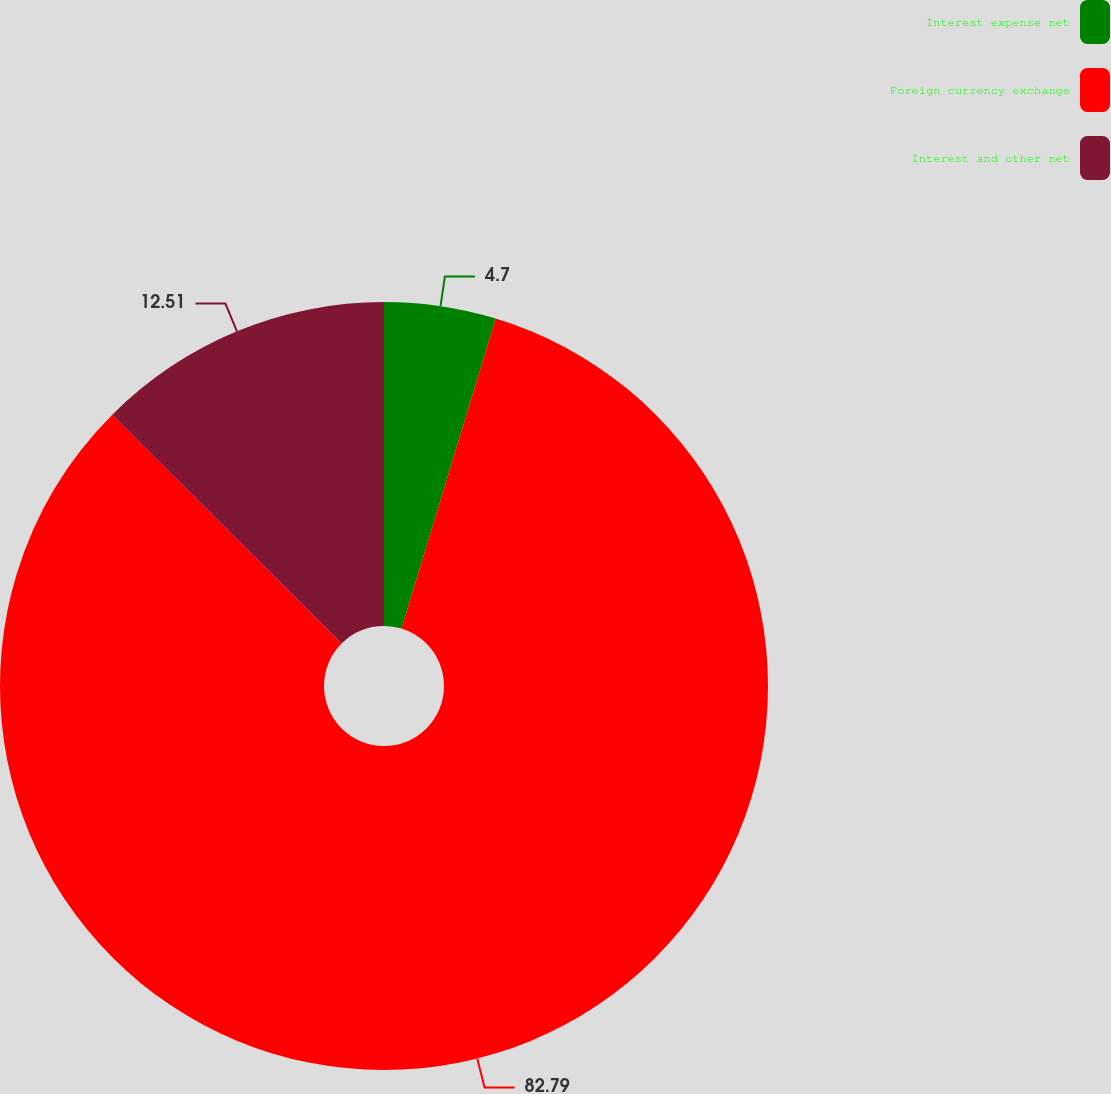Convert chart. <chart><loc_0><loc_0><loc_500><loc_500><pie_chart><fcel>Interest expense net<fcel>Foreign currency exchange<fcel>Interest and other net<nl><fcel>4.7%<fcel>82.79%<fcel>12.51%<nl></chart> 